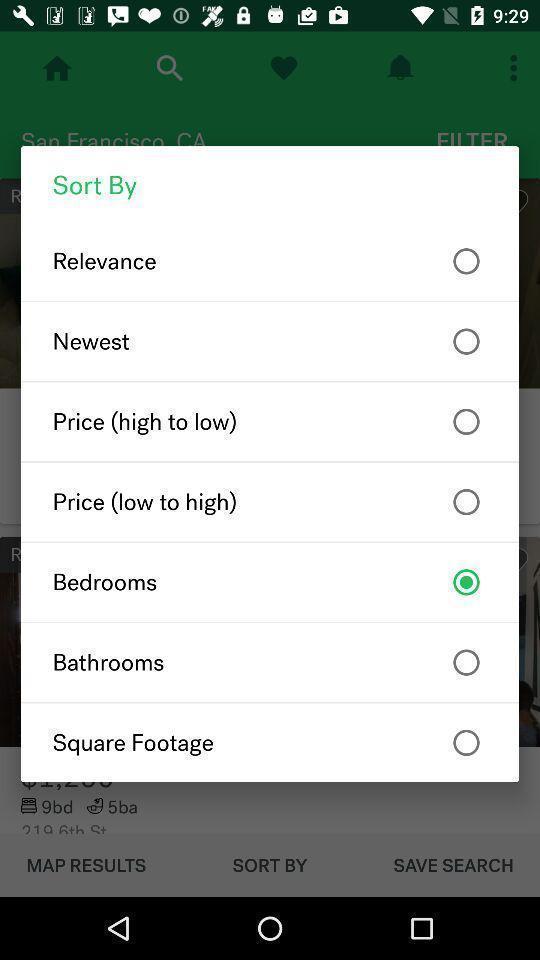Describe the content in this image. Pop-up shows different options. 